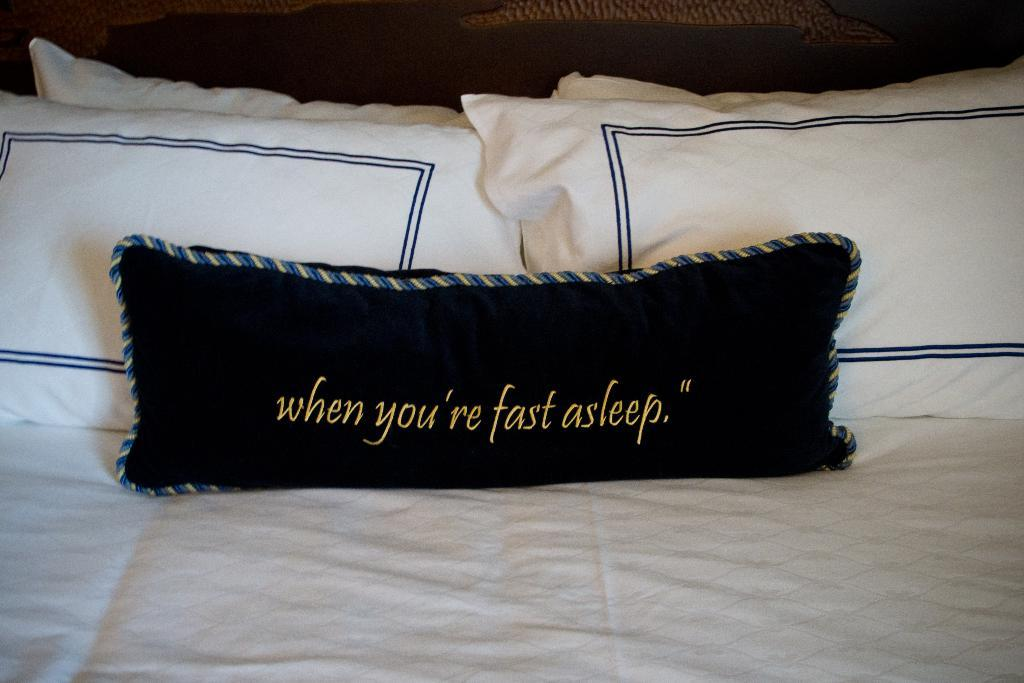What color is the bed in the image? The bed in the image is white. How many pillows are on the bed? There are four white pillows and one black pillow on the bed. What is unique about the black pillow? The black pillow has something written on it. What type of prose can be found in the books on the library shelf in the image? There are no books or library shelves present in the image. 